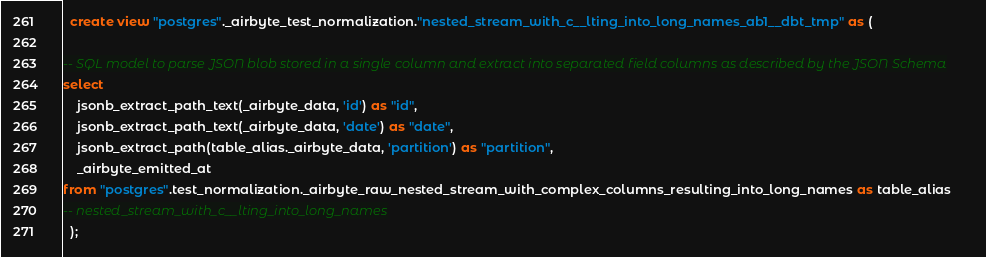Convert code to text. <code><loc_0><loc_0><loc_500><loc_500><_SQL_>
  create view "postgres"._airbyte_test_normalization."nested_stream_with_c__lting_into_long_names_ab1__dbt_tmp" as (
    
-- SQL model to parse JSON blob stored in a single column and extract into separated field columns as described by the JSON Schema
select
    jsonb_extract_path_text(_airbyte_data, 'id') as "id",
    jsonb_extract_path_text(_airbyte_data, 'date') as "date",
    jsonb_extract_path(table_alias._airbyte_data, 'partition') as "partition",
    _airbyte_emitted_at
from "postgres".test_normalization._airbyte_raw_nested_stream_with_complex_columns_resulting_into_long_names as table_alias
-- nested_stream_with_c__lting_into_long_names
  );
</code> 